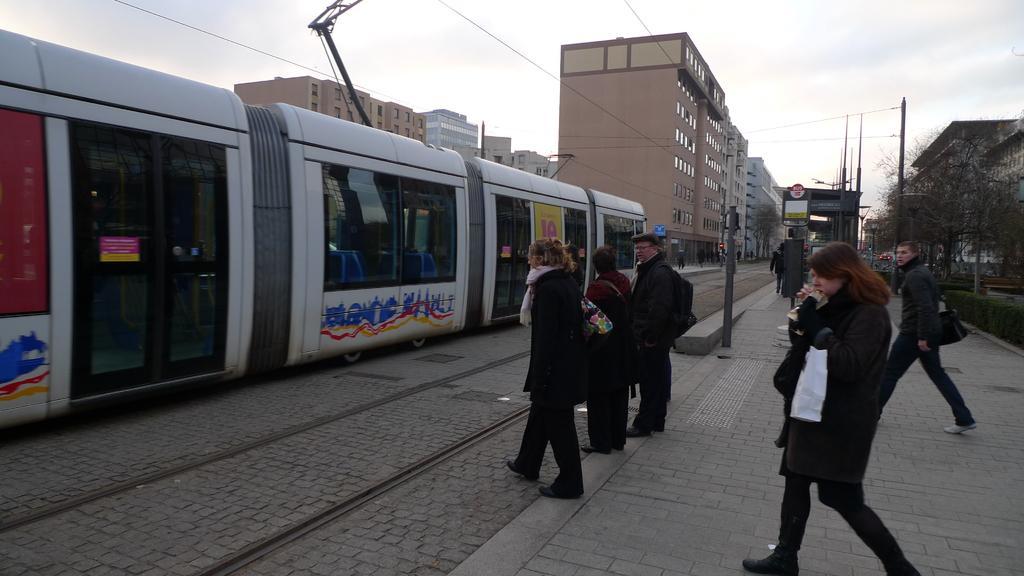Could you give a brief overview of what you see in this image? There is a train on the track. Here we can see few persons. There are poles, trees, boards, and buildings. In the background there is sky. 